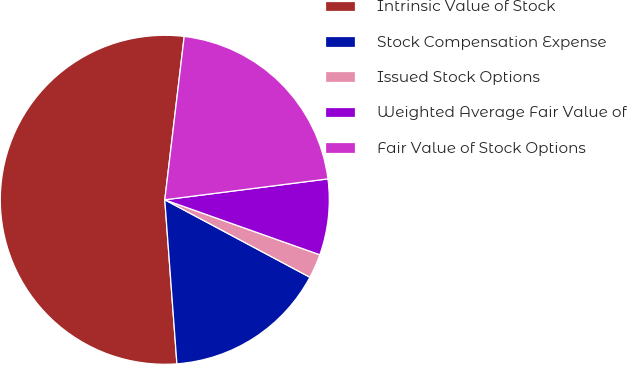<chart> <loc_0><loc_0><loc_500><loc_500><pie_chart><fcel>Intrinsic Value of Stock<fcel>Stock Compensation Expense<fcel>Issued Stock Options<fcel>Weighted Average Fair Value of<fcel>Fair Value of Stock Options<nl><fcel>53.05%<fcel>16.02%<fcel>2.38%<fcel>7.45%<fcel>21.09%<nl></chart> 